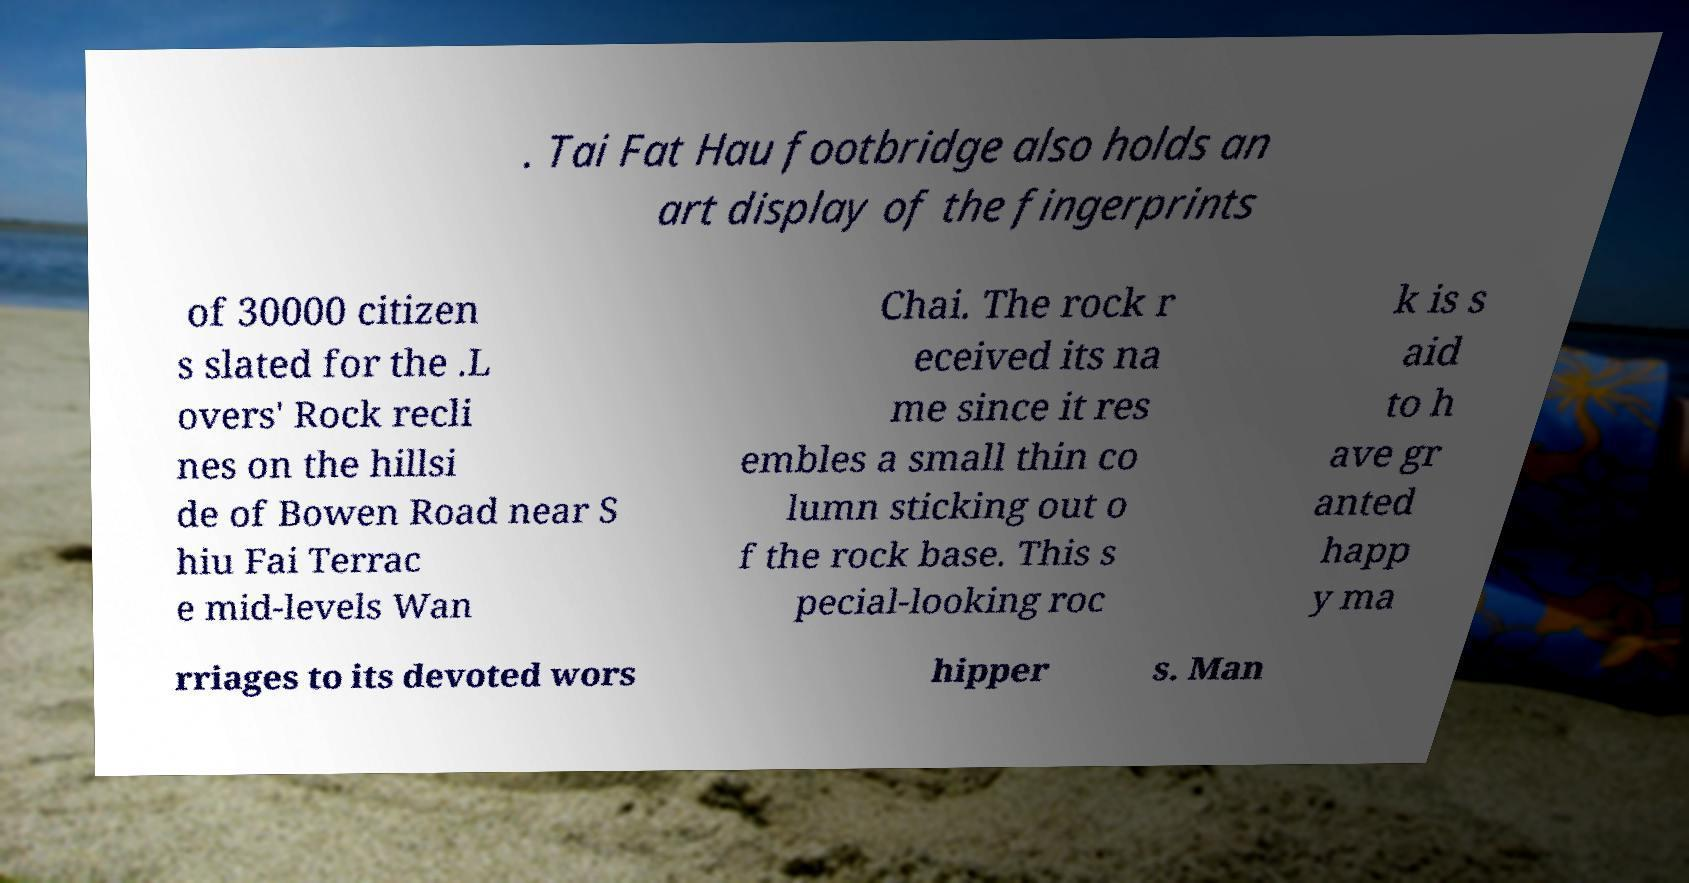Please read and relay the text visible in this image. What does it say? . Tai Fat Hau footbridge also holds an art display of the fingerprints of 30000 citizen s slated for the .L overs' Rock recli nes on the hillsi de of Bowen Road near S hiu Fai Terrac e mid-levels Wan Chai. The rock r eceived its na me since it res embles a small thin co lumn sticking out o f the rock base. This s pecial-looking roc k is s aid to h ave gr anted happ y ma rriages to its devoted wors hipper s. Man 